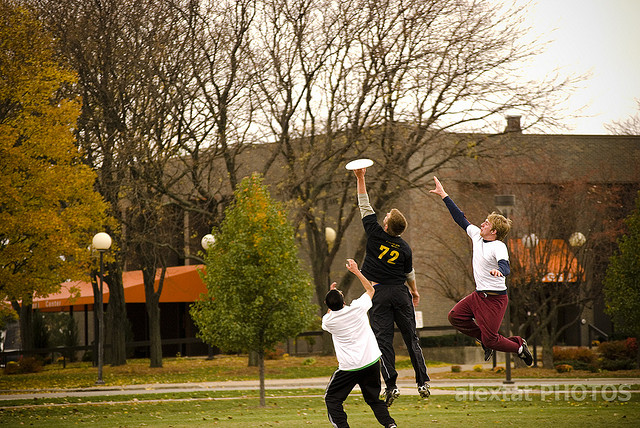Can you describe the setting in which this Frisbee game is taking place? The game is set in a spacious outdoor area with a grassy field, ideal for Frisbee play. Autumn leaves suggest it's fall, providing a vivid and colorful background. In the distance, there are buildings that might indicate this is a college campus or a community park, settings that typically foster such energetic sports and gatherings. 